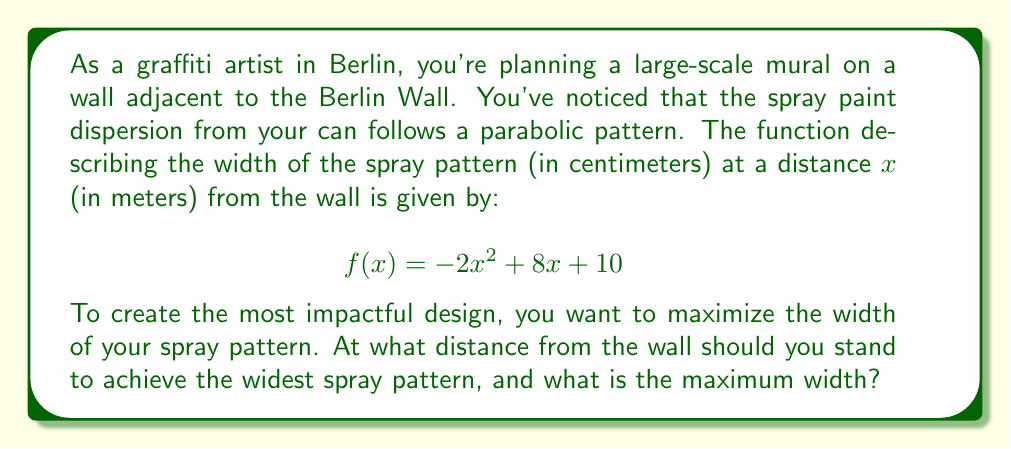Solve this math problem. To solve this problem, we need to find the maximum value of the quadratic function $f(x) = -2x^2 + 8x + 10$. This can be done using the following steps:

1. Identify the quadratic function in standard form: $f(x) = ax^2 + bx + c$
   Here, $a = -2$, $b = 8$, and $c = 10$

2. Calculate the x-coordinate of the vertex using the formula: $x = -\frac{b}{2a}$
   $$x = -\frac{8}{2(-2)} = -\frac{8}{-4} = 2$$

3. The x-coordinate (2) represents the distance from the wall where the spray pattern is widest.

4. To find the maximum width, substitute x = 2 into the original function:
   $$f(2) = -2(2)^2 + 8(2) + 10$$
   $$f(2) = -2(4) + 16 + 10$$
   $$f(2) = -8 + 16 + 10 = 18$$

5. Verify this is a maximum (not minimum) because $a < 0$ (opens downward).

[asy]
import graph;
size(200,200);
real f(real x) {return -2x^2+8x+10;}
xaxis("x (meters)",arrow=Arrow);
yaxis("y (cm)",arrow=Arrow);
draw(graph(f,0,4));
dot((2,18),red);
label("(2,18)",(2,18),NE);
[/asy]
Answer: You should stand 2 meters away from the wall to achieve the widest spray pattern, which will have a maximum width of 18 centimeters. 